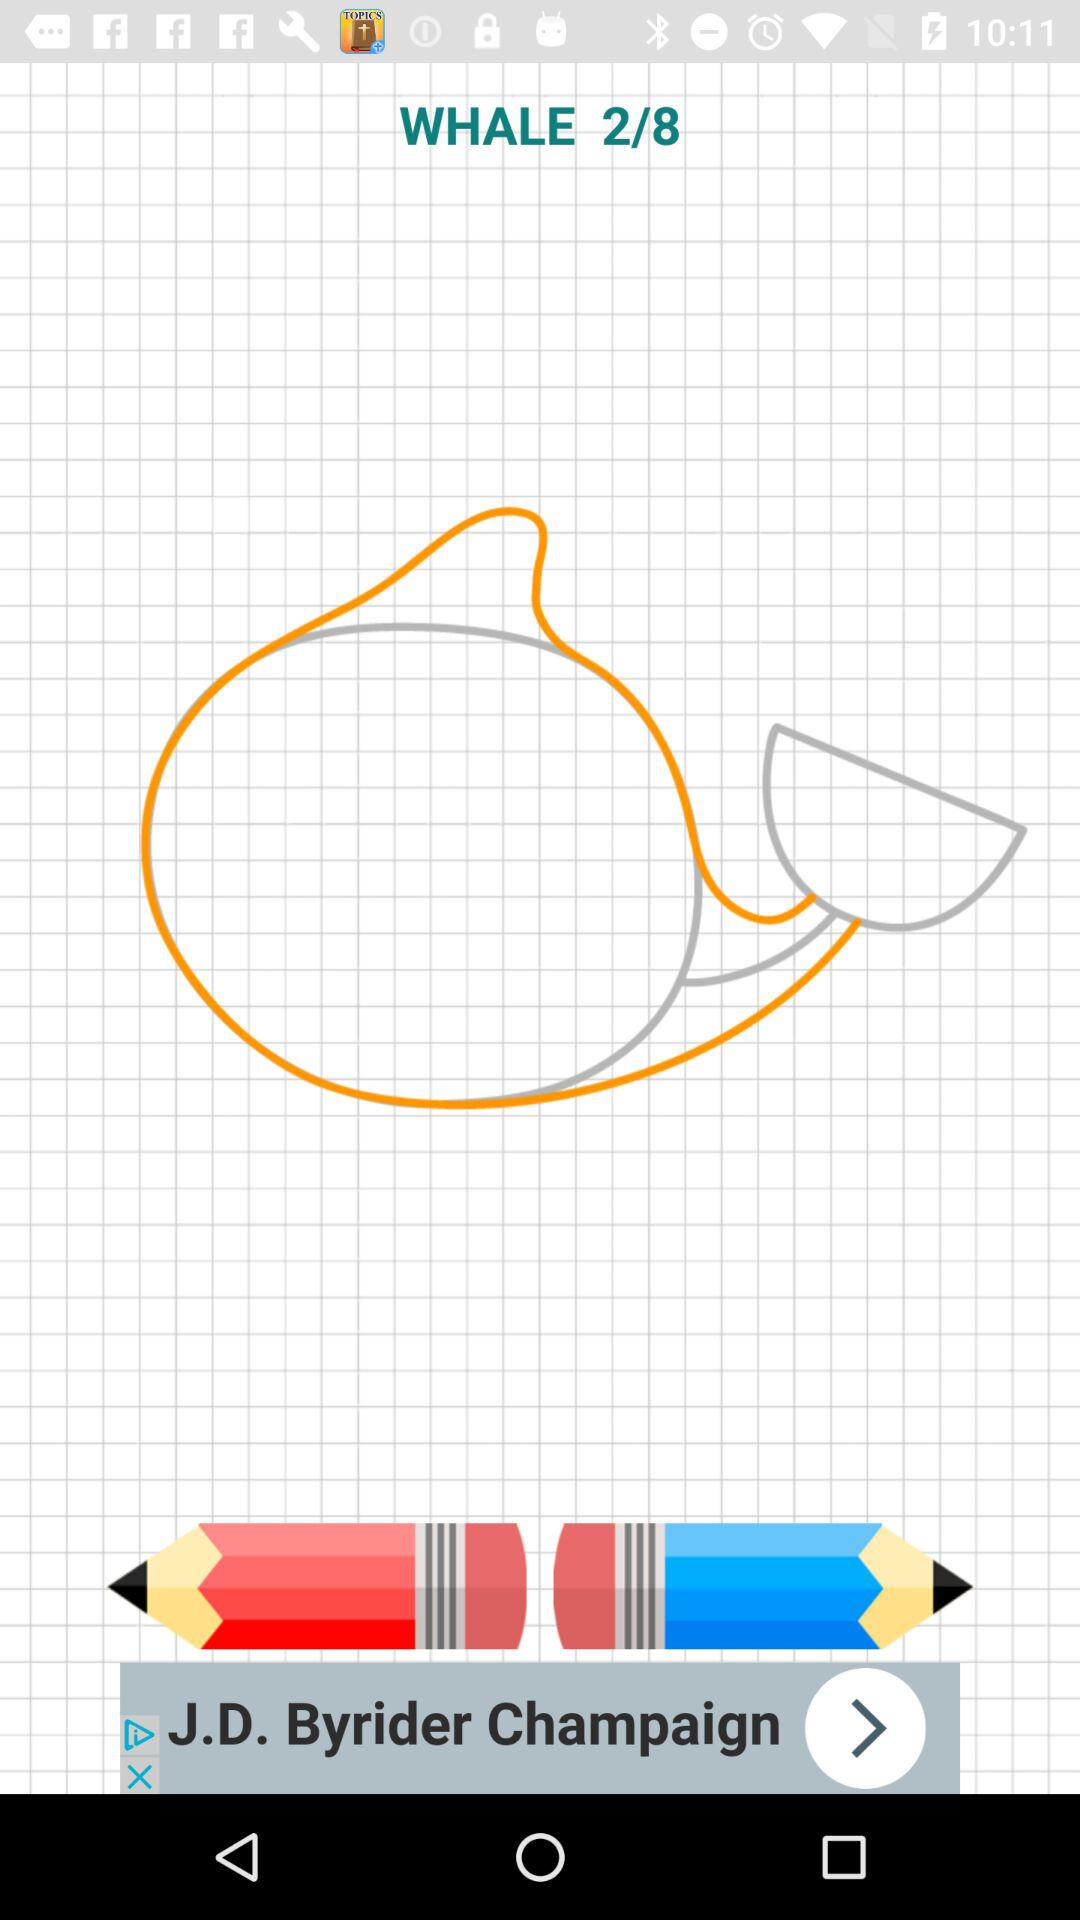Which page am I on? You are on page 2. 